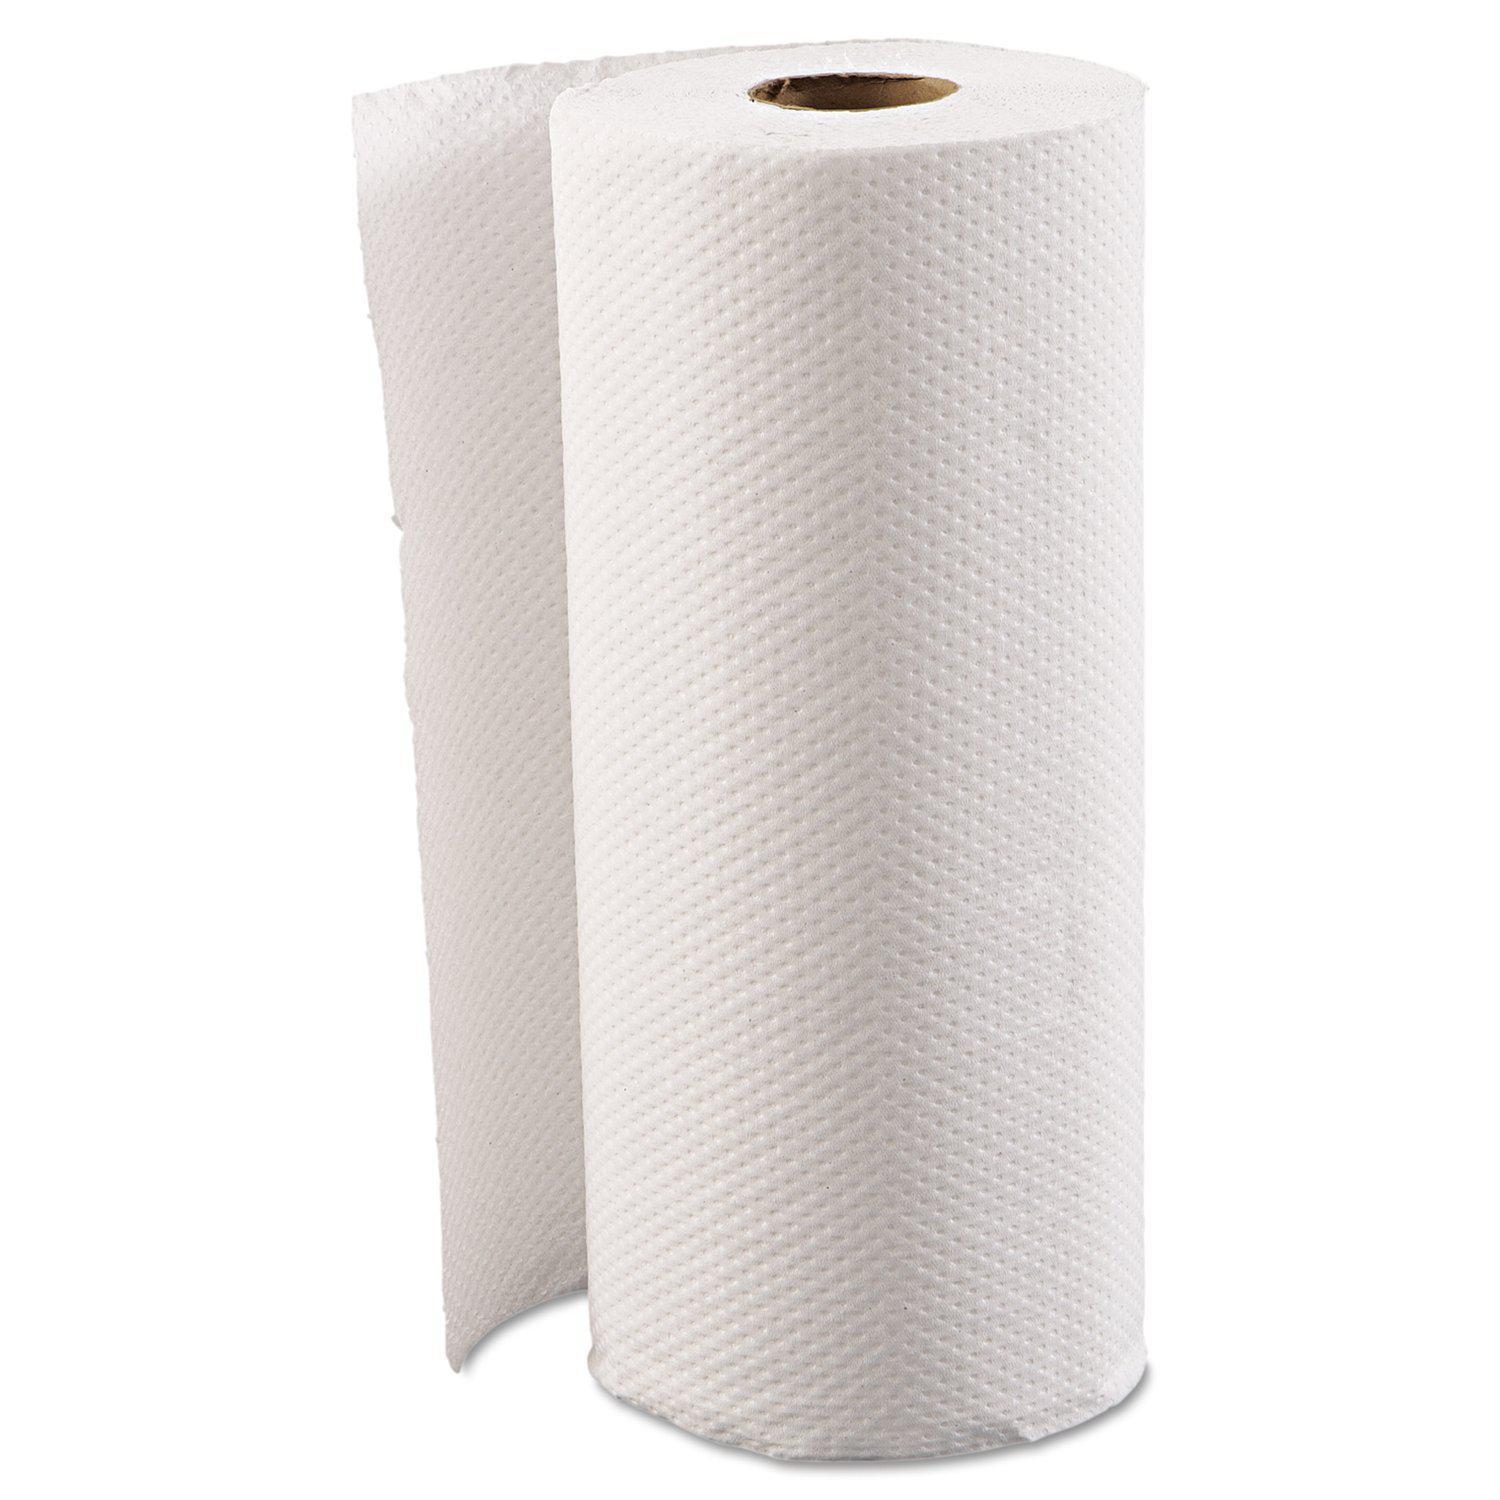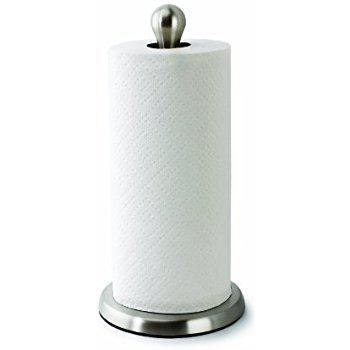The first image is the image on the left, the second image is the image on the right. Given the left and right images, does the statement "There are two rolls of paper towels." hold true? Answer yes or no. Yes. 